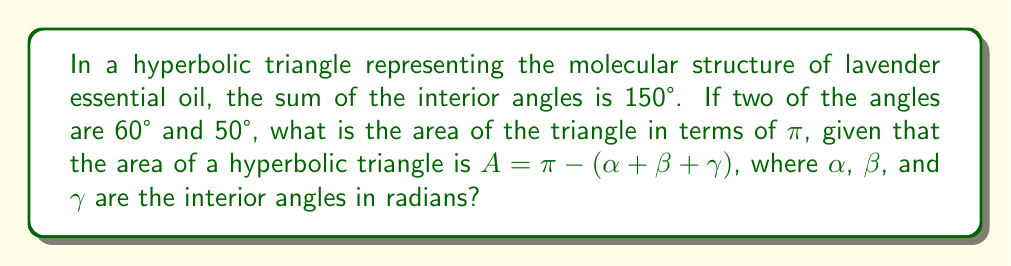Provide a solution to this math problem. 1. First, let's identify the given information:
   - Sum of interior angles = 150°
   - Two angles: 60° and 50°
   - Area formula: $A = \pi - (\alpha + \beta + \gamma)$

2. Calculate the third angle:
   $150° - (60° + 50°) = 40°$

3. Convert all angles to radians:
   $60° = \frac{\pi}{3}$ rad
   $50° = \frac{5\pi}{18}$ rad
   $40° = \frac{2\pi}{9}$ rad

4. Sum of angles in radians:
   $\alpha + \beta + \gamma = \frac{\pi}{3} + \frac{5\pi}{18} + \frac{2\pi}{9} = \frac{5\pi}{6}$

5. Apply the area formula:
   $A = \pi - (\frac{5\pi}{6})$

6. Simplify:
   $A = \pi - \frac{5\pi}{6} = \frac{\pi}{6}$

Therefore, the area of the hyperbolic triangle representing the molecular structure of lavender essential oil is $\frac{\pi}{6}$.
Answer: $\frac{\pi}{6}$ 